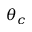<formula> <loc_0><loc_0><loc_500><loc_500>\theta _ { c }</formula> 